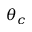<formula> <loc_0><loc_0><loc_500><loc_500>\theta _ { c }</formula> 